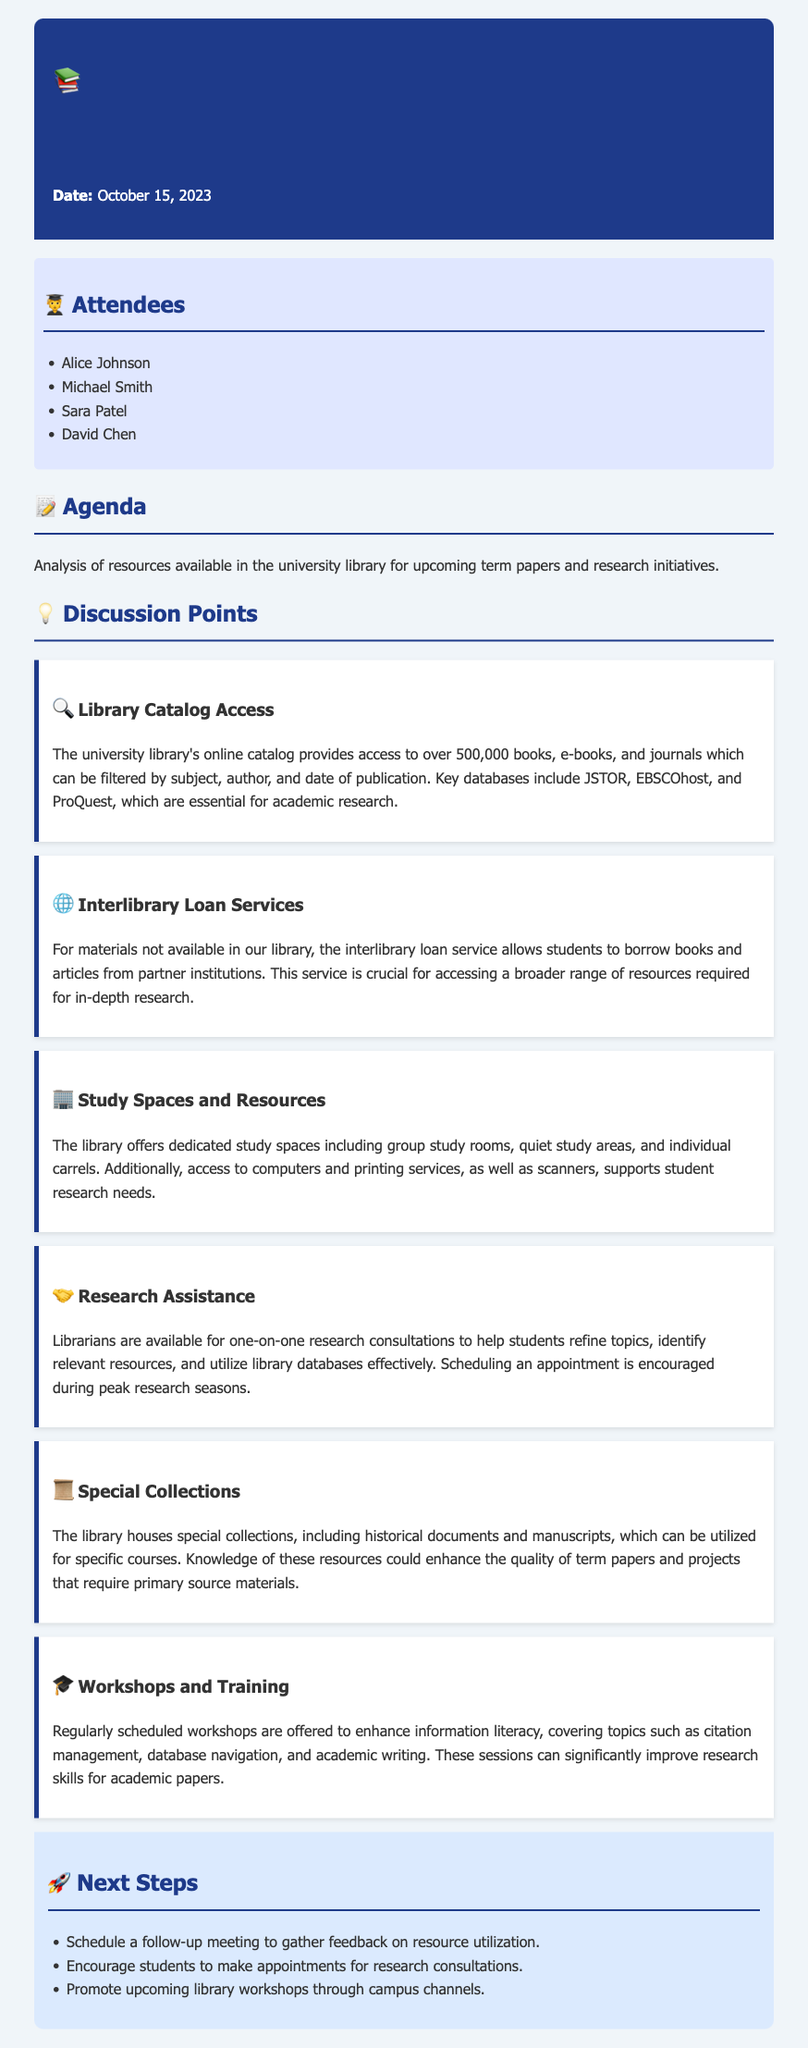What is the date of the meeting? The date of the meeting is explicitly stated at the beginning of the document.
Answer: October 15, 2023 How many attendees are listed in the document? The number of attendees can be counted from the list provided in the attendees section.
Answer: Four What is the title of the first discussion point? The title of the first discussion point is found in the discussion points section.
Answer: Library Catalog Access Which service allows students to borrow materials from partner institutions? The discussion mentions a specific service related to accessing external resources.
Answer: Interlibrary Loan Services What type of spaces does the library offer for studying? The available study spaces are specified within the discussion points concerning study resources.
Answer: Dedicated study spaces What is encouraged during peak research seasons? A specific action is recommended for students during busy research times.
Answer: Scheduling an appointment What do the library workshops aim to enhance? The purpose of the workshops is detailed in the corresponding discussion point.
Answer: Information literacy Which collections can enhance the quality of term papers? The document mentions specific resources that can be used for in-depth research.
Answer: Special collections 